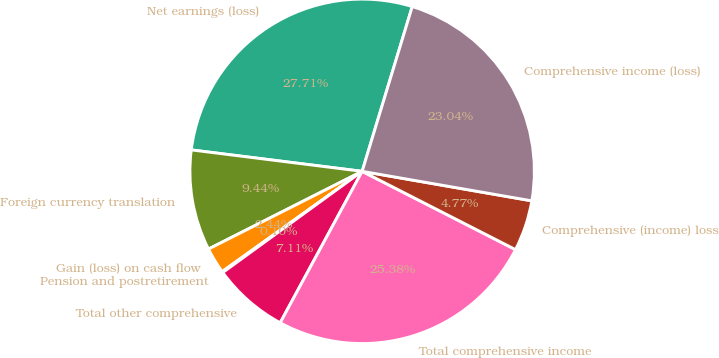Convert chart. <chart><loc_0><loc_0><loc_500><loc_500><pie_chart><fcel>Net earnings (loss)<fcel>Foreign currency translation<fcel>Gain (loss) on cash flow<fcel>Pension and postretirement<fcel>Total other comprehensive<fcel>Total comprehensive income<fcel>Comprehensive (income) loss<fcel>Comprehensive income (loss)<nl><fcel>27.71%<fcel>9.44%<fcel>2.44%<fcel>0.1%<fcel>7.11%<fcel>25.38%<fcel>4.77%<fcel>23.04%<nl></chart> 